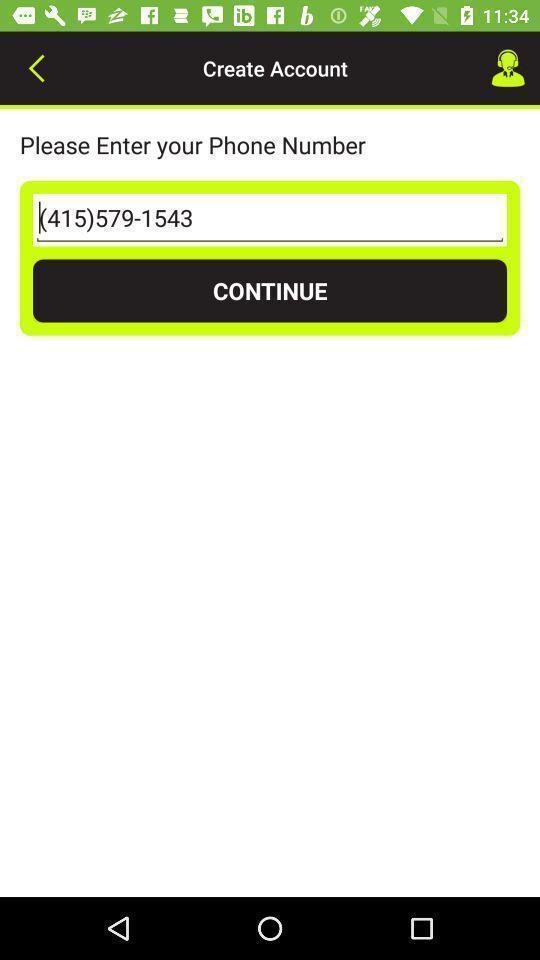What details can you identify in this image? Page displaying to enter phone number and continue. 